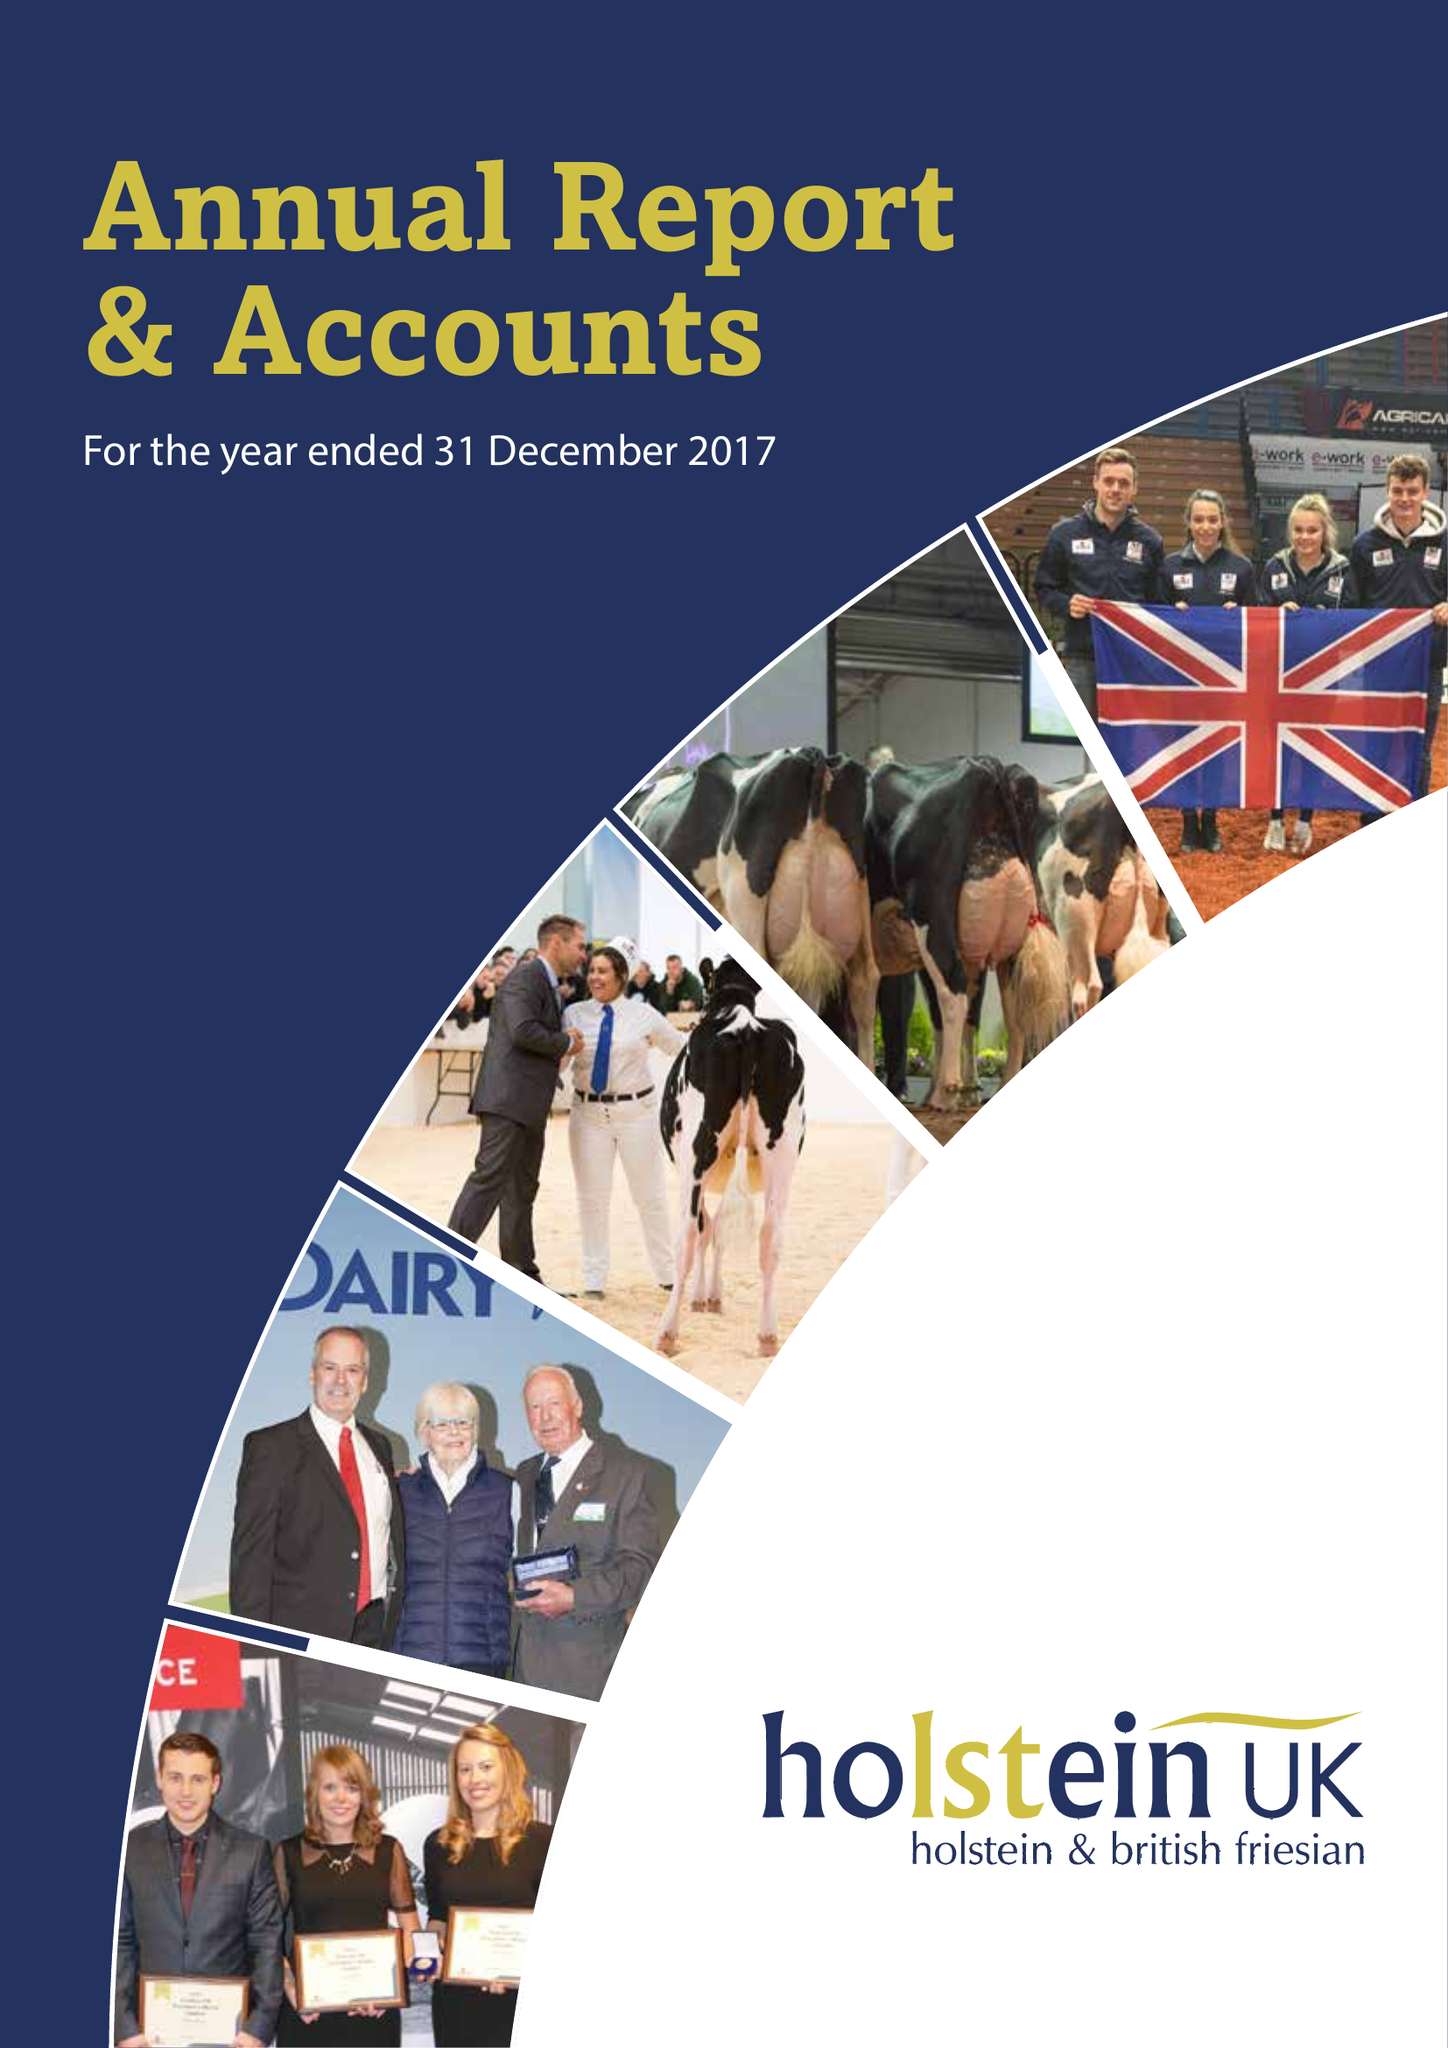What is the value for the spending_annually_in_british_pounds?
Answer the question using a single word or phrase. 11179318.00 